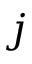<formula> <loc_0><loc_0><loc_500><loc_500>j</formula> 